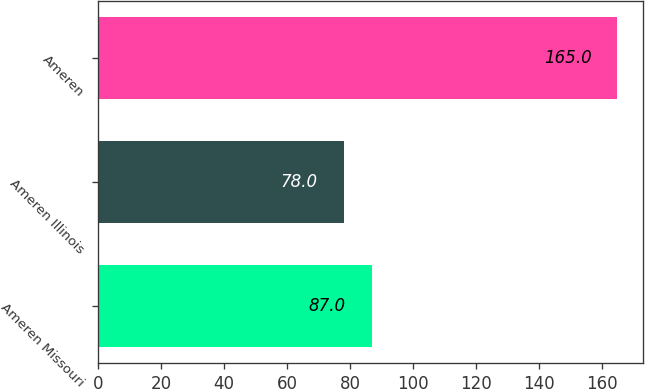Convert chart to OTSL. <chart><loc_0><loc_0><loc_500><loc_500><bar_chart><fcel>Ameren Missouri<fcel>Ameren Illinois<fcel>Ameren<nl><fcel>87<fcel>78<fcel>165<nl></chart> 